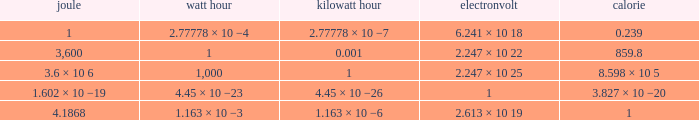What is the number of calories in a single watt hour? 859.8. 